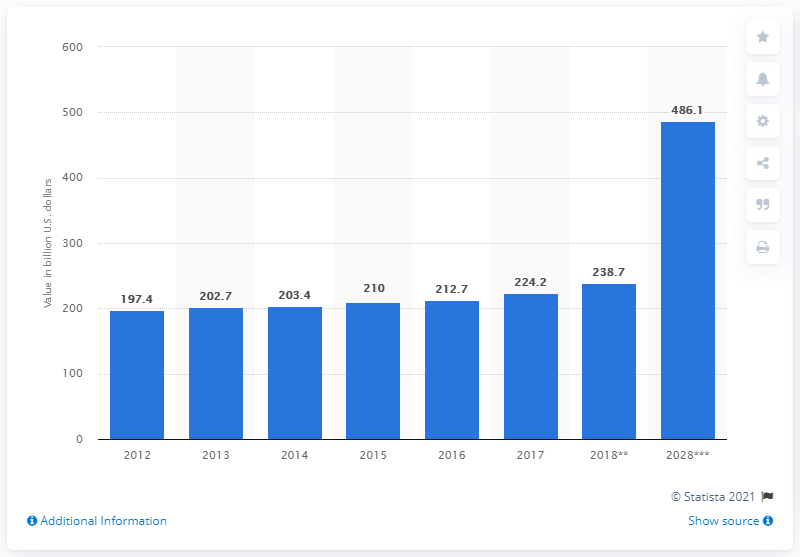Point out several critical features in this image. The total contribution of travel and tourism to the GDP of Middle Eastern countries is forecasted to reach $486.1 billion by 2028, according to estimates. 